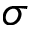Convert formula to latex. <formula><loc_0><loc_0><loc_500><loc_500>\sigma</formula> 